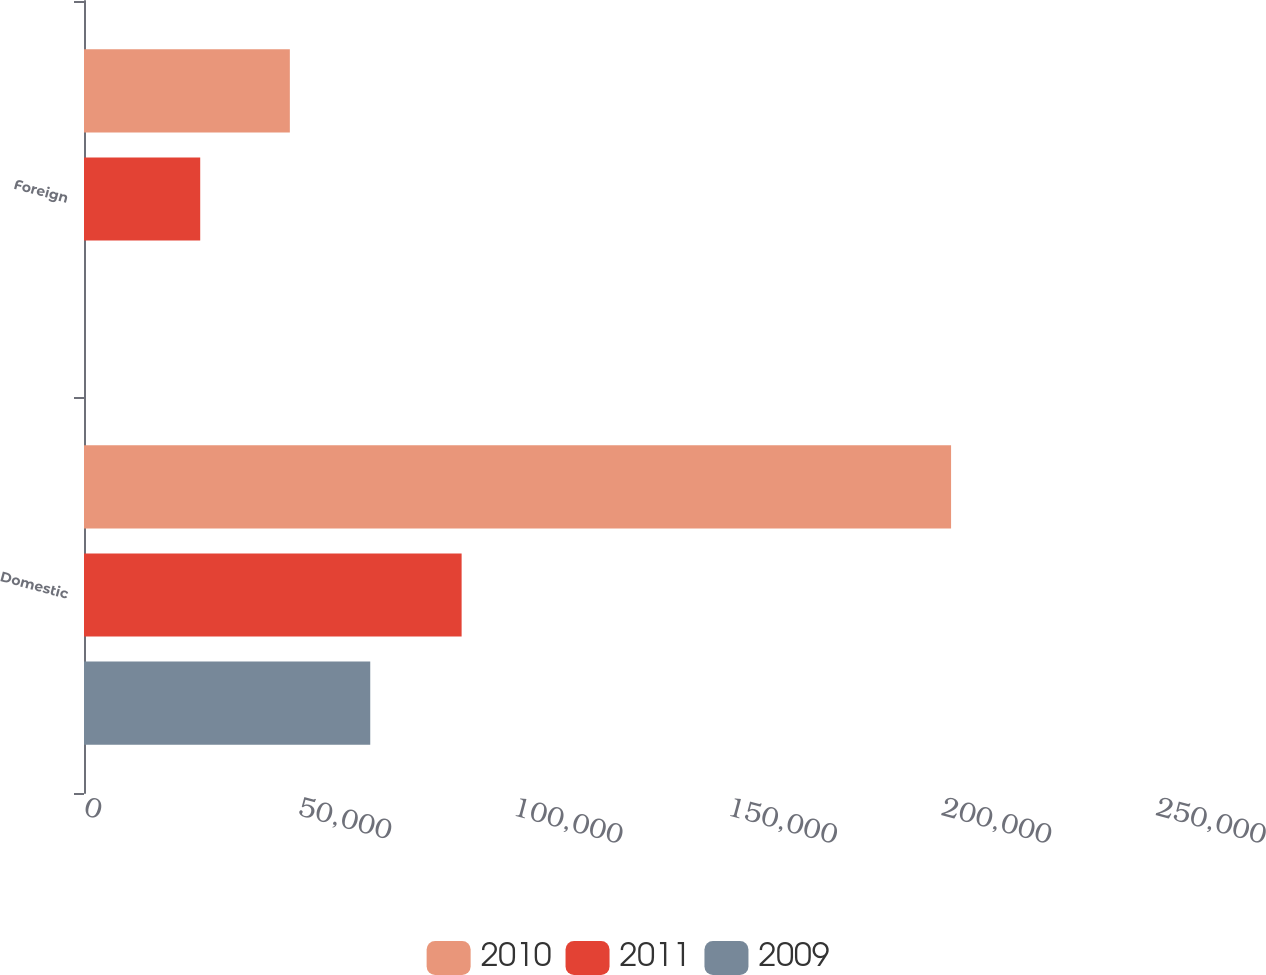Convert chart. <chart><loc_0><loc_0><loc_500><loc_500><stacked_bar_chart><ecel><fcel>Domestic<fcel>Foreign<nl><fcel>2010<fcel>202210<fcel>48006<nl><fcel>2011<fcel>88065<fcel>27103<nl><fcel>2009<fcel>66756<fcel>7<nl></chart> 